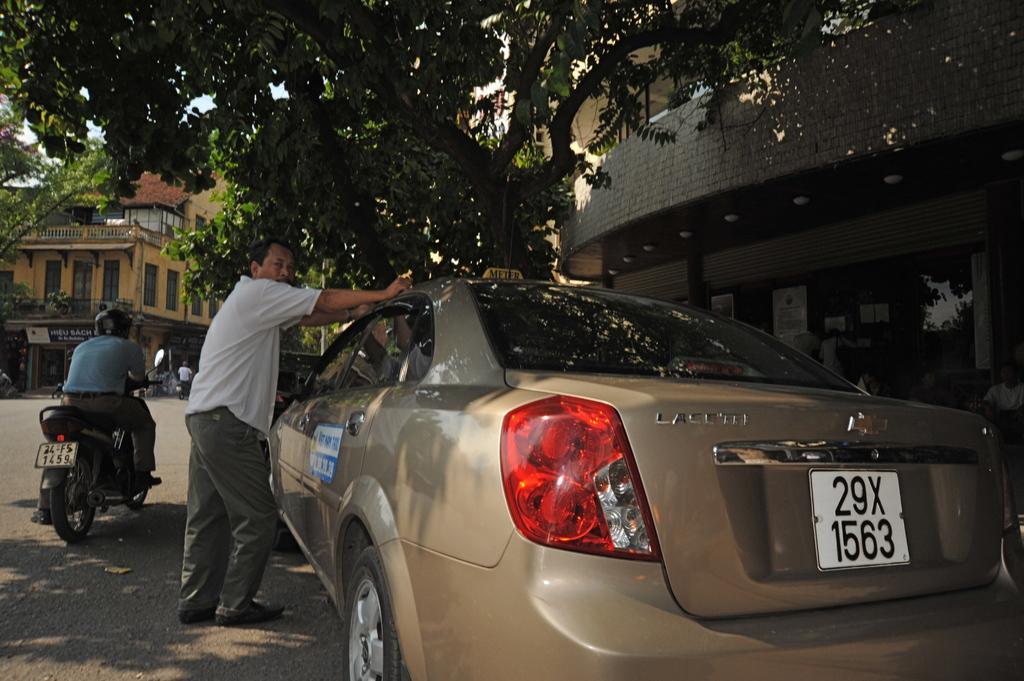Please provide a concise description of this image. This is a picture consist of a building on the right side. on the left side there is a another building and a man sit on the bike and a bike is stand on the floor and there is a car visible and a man stand in front of the car and there is a tree in front of the car. 